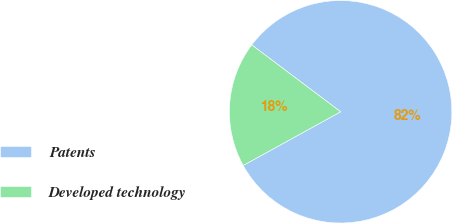<chart> <loc_0><loc_0><loc_500><loc_500><pie_chart><fcel>Patents<fcel>Developed technology<nl><fcel>81.72%<fcel>18.28%<nl></chart> 